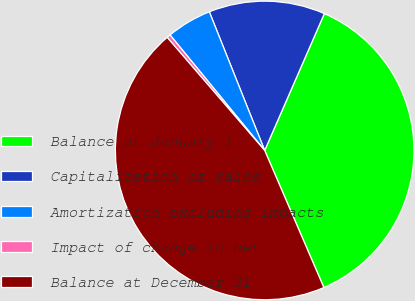Convert chart to OTSL. <chart><loc_0><loc_0><loc_500><loc_500><pie_chart><fcel>Balance at January 1<fcel>Capitalization of sales<fcel>Amortization excluding impacts<fcel>Impact of change in net<fcel>Balance at December 31<nl><fcel>36.97%<fcel>12.59%<fcel>4.88%<fcel>0.4%<fcel>45.16%<nl></chart> 